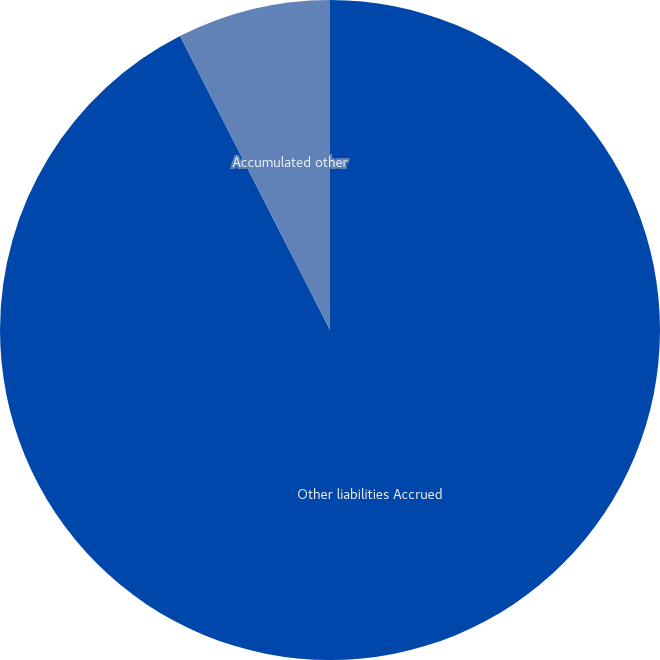Convert chart. <chart><loc_0><loc_0><loc_500><loc_500><pie_chart><fcel>Other liabilities Accrued<fcel>Accumulated other<nl><fcel>92.49%<fcel>7.51%<nl></chart> 